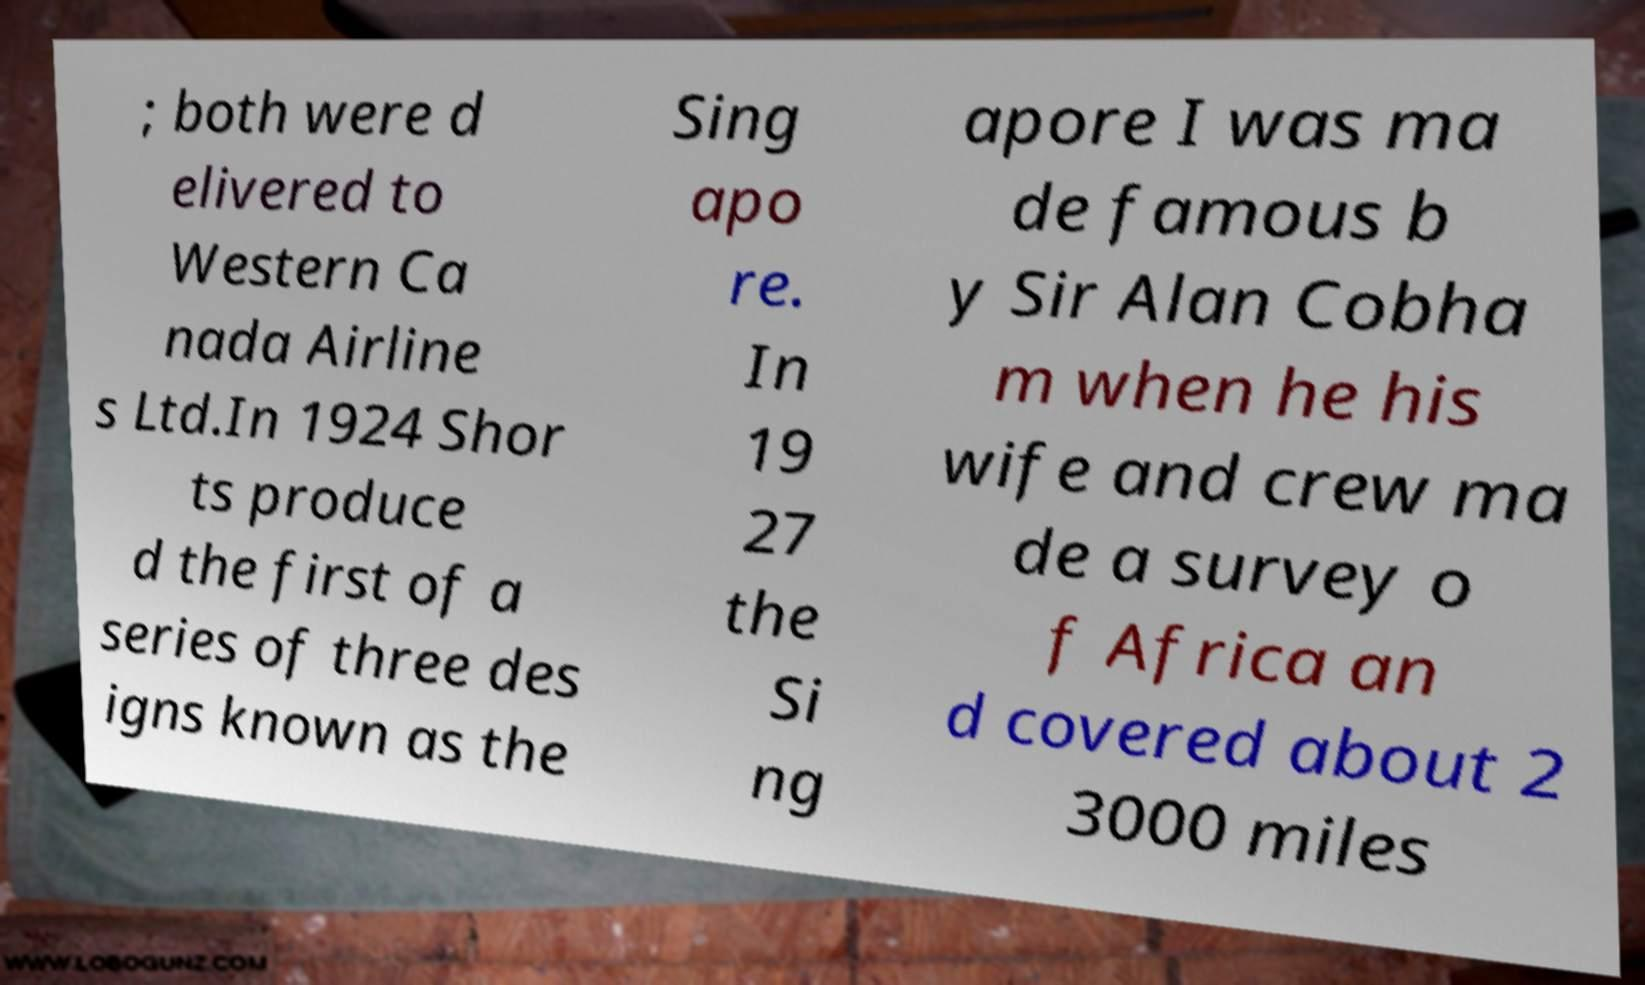Can you read and provide the text displayed in the image?This photo seems to have some interesting text. Can you extract and type it out for me? ; both were d elivered to Western Ca nada Airline s Ltd.In 1924 Shor ts produce d the first of a series of three des igns known as the Sing apo re. In 19 27 the Si ng apore I was ma de famous b y Sir Alan Cobha m when he his wife and crew ma de a survey o f Africa an d covered about 2 3000 miles 